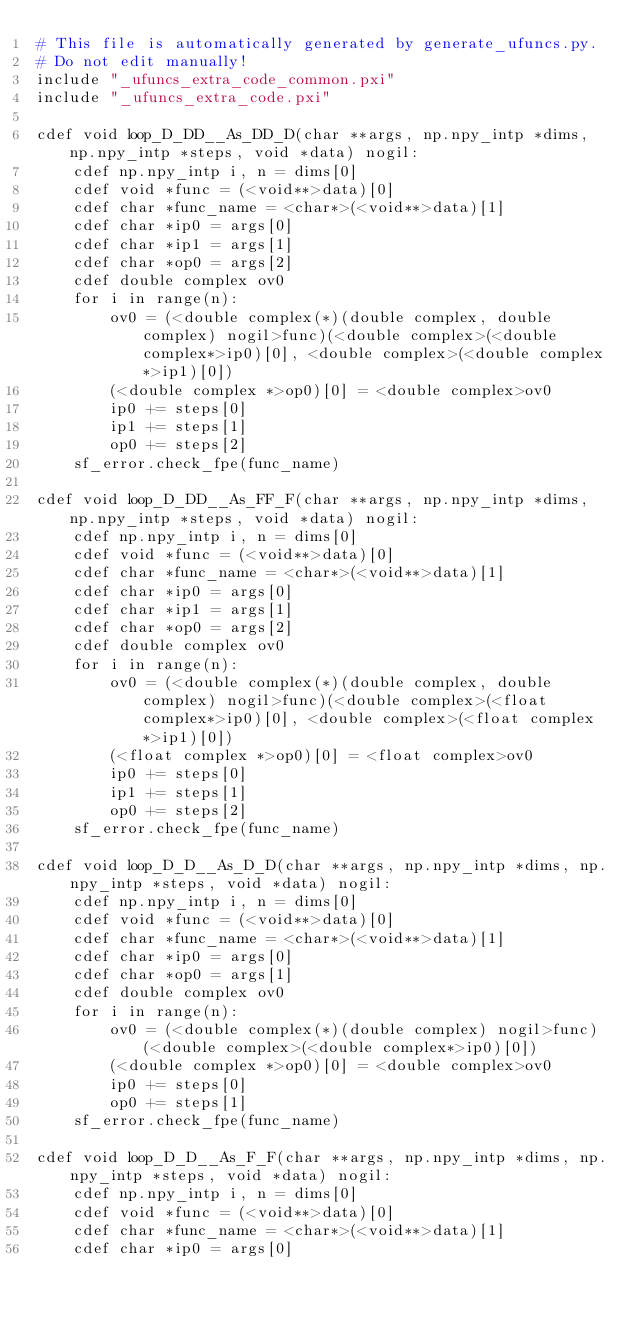Convert code to text. <code><loc_0><loc_0><loc_500><loc_500><_Cython_># This file is automatically generated by generate_ufuncs.py.
# Do not edit manually!
include "_ufuncs_extra_code_common.pxi"
include "_ufuncs_extra_code.pxi"

cdef void loop_D_DD__As_DD_D(char **args, np.npy_intp *dims, np.npy_intp *steps, void *data) nogil:
    cdef np.npy_intp i, n = dims[0]
    cdef void *func = (<void**>data)[0]
    cdef char *func_name = <char*>(<void**>data)[1]
    cdef char *ip0 = args[0]
    cdef char *ip1 = args[1]
    cdef char *op0 = args[2]
    cdef double complex ov0
    for i in range(n):
        ov0 = (<double complex(*)(double complex, double complex) nogil>func)(<double complex>(<double complex*>ip0)[0], <double complex>(<double complex*>ip1)[0])
        (<double complex *>op0)[0] = <double complex>ov0
        ip0 += steps[0]
        ip1 += steps[1]
        op0 += steps[2]
    sf_error.check_fpe(func_name)

cdef void loop_D_DD__As_FF_F(char **args, np.npy_intp *dims, np.npy_intp *steps, void *data) nogil:
    cdef np.npy_intp i, n = dims[0]
    cdef void *func = (<void**>data)[0]
    cdef char *func_name = <char*>(<void**>data)[1]
    cdef char *ip0 = args[0]
    cdef char *ip1 = args[1]
    cdef char *op0 = args[2]
    cdef double complex ov0
    for i in range(n):
        ov0 = (<double complex(*)(double complex, double complex) nogil>func)(<double complex>(<float complex*>ip0)[0], <double complex>(<float complex*>ip1)[0])
        (<float complex *>op0)[0] = <float complex>ov0
        ip0 += steps[0]
        ip1 += steps[1]
        op0 += steps[2]
    sf_error.check_fpe(func_name)

cdef void loop_D_D__As_D_D(char **args, np.npy_intp *dims, np.npy_intp *steps, void *data) nogil:
    cdef np.npy_intp i, n = dims[0]
    cdef void *func = (<void**>data)[0]
    cdef char *func_name = <char*>(<void**>data)[1]
    cdef char *ip0 = args[0]
    cdef char *op0 = args[1]
    cdef double complex ov0
    for i in range(n):
        ov0 = (<double complex(*)(double complex) nogil>func)(<double complex>(<double complex*>ip0)[0])
        (<double complex *>op0)[0] = <double complex>ov0
        ip0 += steps[0]
        op0 += steps[1]
    sf_error.check_fpe(func_name)

cdef void loop_D_D__As_F_F(char **args, np.npy_intp *dims, np.npy_intp *steps, void *data) nogil:
    cdef np.npy_intp i, n = dims[0]
    cdef void *func = (<void**>data)[0]
    cdef char *func_name = <char*>(<void**>data)[1]
    cdef char *ip0 = args[0]</code> 